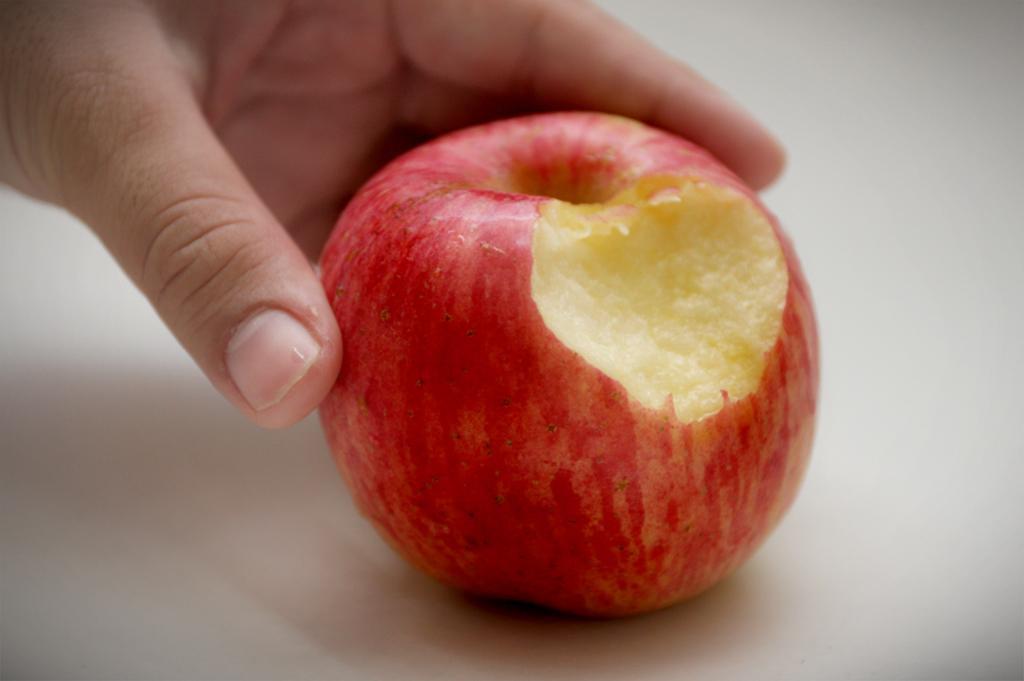Please provide a concise description of this image. In this image I see a person's hand who is holding an apple which is of red and cream in color and I see that this apple is on the white surface. 